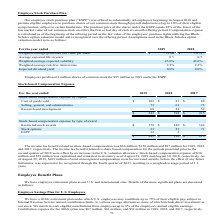Looking at Micron Technology's financial data, please calculate: What is the percentage change in stock-based compensation expense from 2017 to 2018? To answer this question, I need to perform calculations using the financial data. The calculation is: ($198-$215)/$215 , which equals -7.91 (percentage). This is based on the information: "$ 243 $ 198 $ 215 $ 243 $ 198 $ 215..." The key data points involved are: 198, 215. Also, can you calculate: What is the difference between stock-based compensation expenses between 2018 and 2019? Based on the calculation: $243-$198 , the result is 45 (in millions). This is based on the information: "$ 243 $ 198 $ 215 $ 243 $ 198 $ 215..." The key data points involved are: 198, 243. Also, What was the stock-based compensation expense of ESPP by type of reward in 2019? According to the financial document, 32 (in millions). The relevant text states: "ESPP 32 3 —..." Also, How much stock-based compensation expense was capitalized and remained in inventory as of August 29, 2019? According to the financial document, $30 million. The relevant text states: "ion allowance. Stock-based compensation expense of $30 million and $19 million was capitalized and remained in inventory as of August 29, 2019 and August 30, 2018,..." Also, How much was the income tax benefit related to share-based compensation in 2018 and 2017 respectively? The document shows two values: $158 million and $97 million. From the document: "lated to share-based compensation was $66 million, $158 million and $97 million for 2019, 2018 sed compensation was $66 million, $158 million and $97 ..." Also, can you calculate: What is the proportion of income tax benefit related to share-based compensation over the total stock-based compensation expense in 2019? Based on the calculation: 66/243 , the result is 0.27. This is based on the information: "$ 243 $ 198 $ 215 benefit related to share-based compensation was $66 million, $158 million and $97 million for 2019, 2018..." The key data points involved are: 243, 66. 